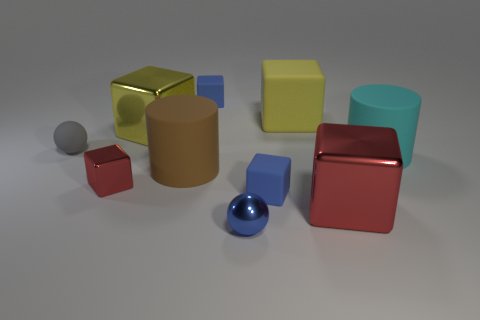Are there any yellow metallic things that have the same size as the cyan matte cylinder?
Provide a short and direct response. Yes. There is a small block that is to the left of the brown object; is it the same color as the metallic ball?
Your response must be concise. No. The metallic thing that is both in front of the cyan object and behind the large red metal block is what color?
Provide a succinct answer. Red. There is a red metal object that is the same size as the cyan rubber object; what is its shape?
Ensure brevity in your answer.  Cube. Is there a large cyan metallic thing of the same shape as the brown thing?
Give a very brief answer. No. There is a blue rubber cube behind the cyan cylinder; is its size the same as the large matte block?
Make the answer very short. No. There is a matte object that is to the left of the small blue ball and behind the small gray object; what size is it?
Provide a short and direct response. Small. How many other objects are there of the same material as the cyan thing?
Your answer should be compact. 5. There is a sphere to the left of the tiny blue ball; what is its size?
Your answer should be very brief. Small. Do the matte sphere and the small metallic block have the same color?
Keep it short and to the point. No. 